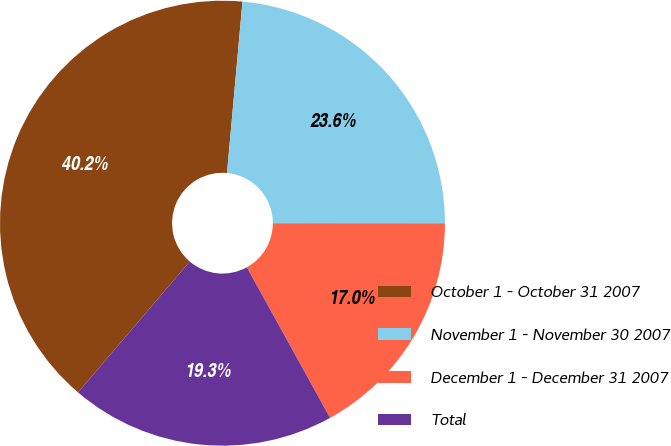Convert chart to OTSL. <chart><loc_0><loc_0><loc_500><loc_500><pie_chart><fcel>October 1 - October 31 2007<fcel>November 1 - November 30 2007<fcel>December 1 - December 31 2007<fcel>Total<nl><fcel>40.19%<fcel>23.57%<fcel>16.96%<fcel>19.28%<nl></chart> 